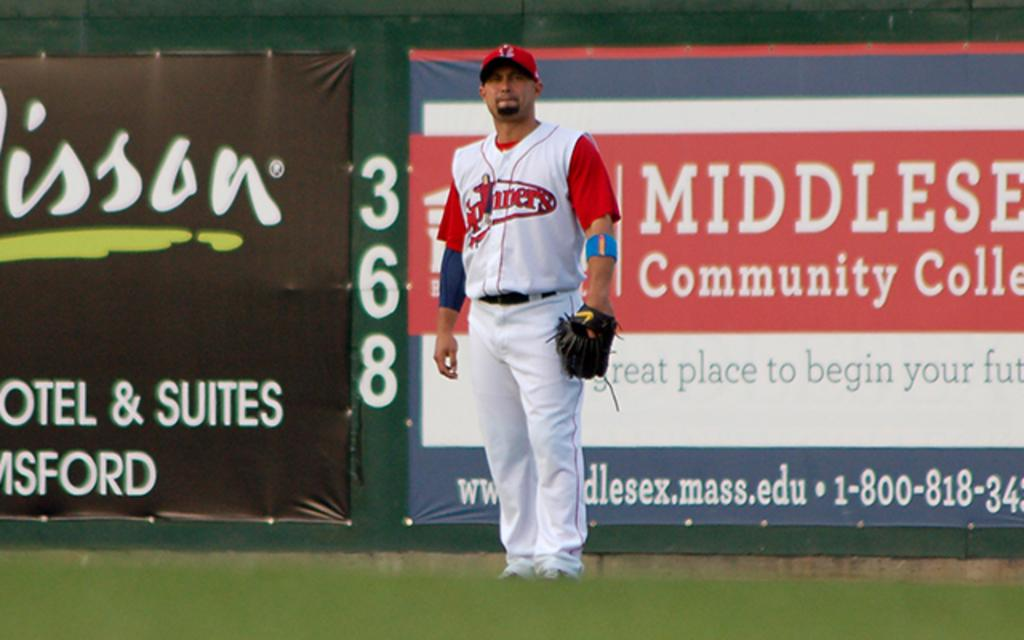<image>
Provide a brief description of the given image. A baseball player standing in a stadium in front of an advertisement for Middlesex Community College. 